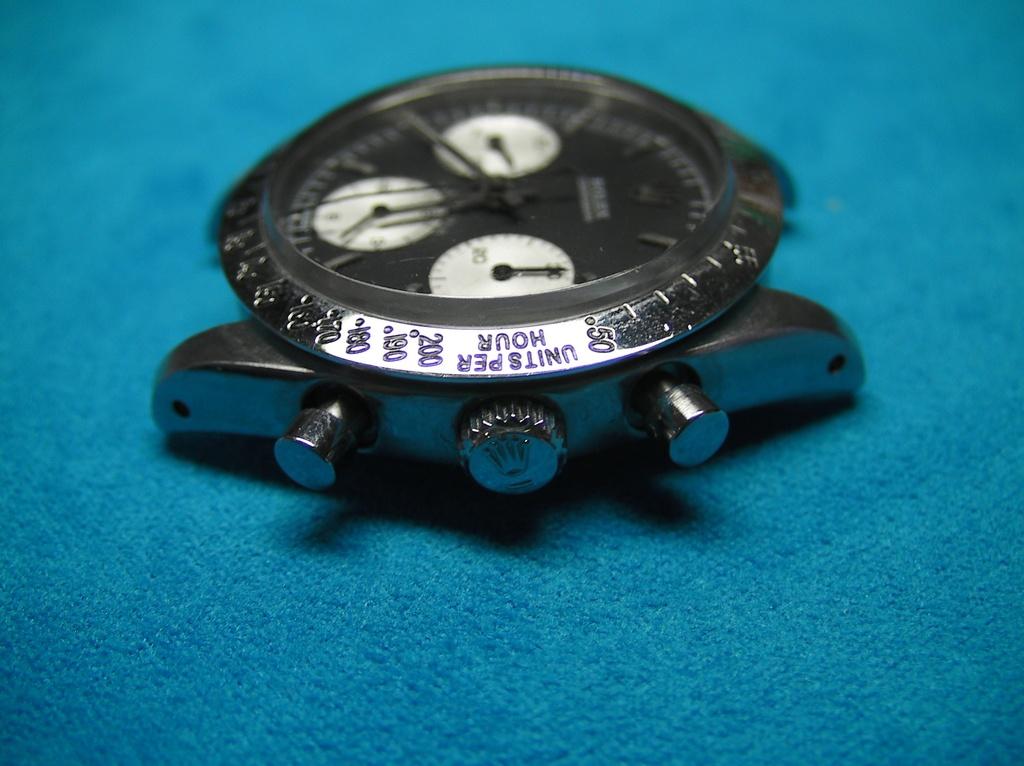In what units are these numbers measured?
Keep it short and to the point. Hour. 